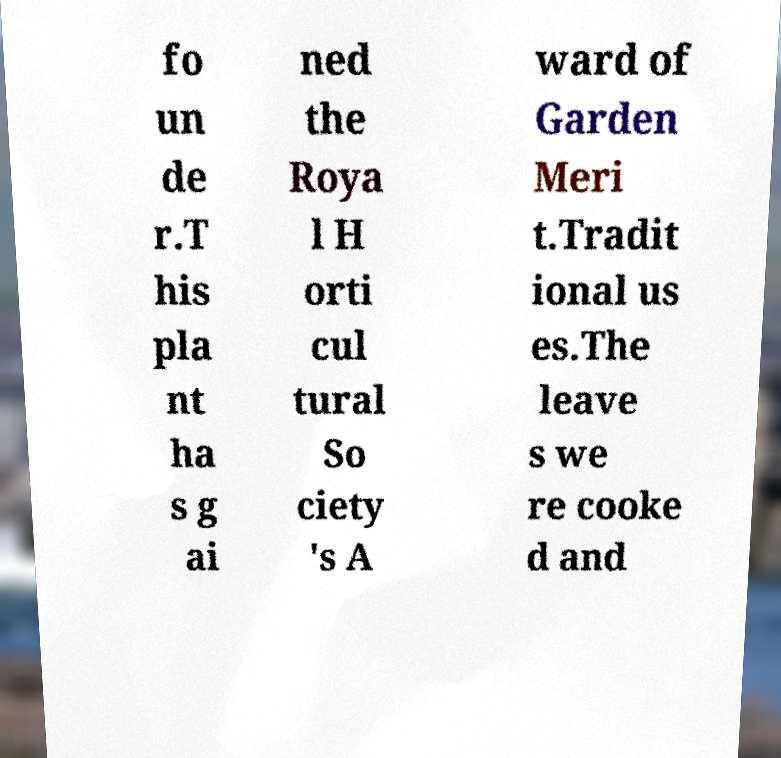Could you extract and type out the text from this image? fo un de r.T his pla nt ha s g ai ned the Roya l H orti cul tural So ciety 's A ward of Garden Meri t.Tradit ional us es.The leave s we re cooke d and 